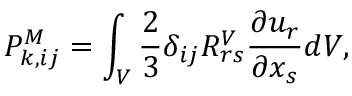<formula> <loc_0><loc_0><loc_500><loc_500>P _ { k , i j } ^ { M } = \int _ { V } \frac { 2 } { 3 } \delta _ { i j } R _ { r s } ^ { V } \frac { \partial u _ { r } } { \partial x _ { s } } d V ,</formula> 